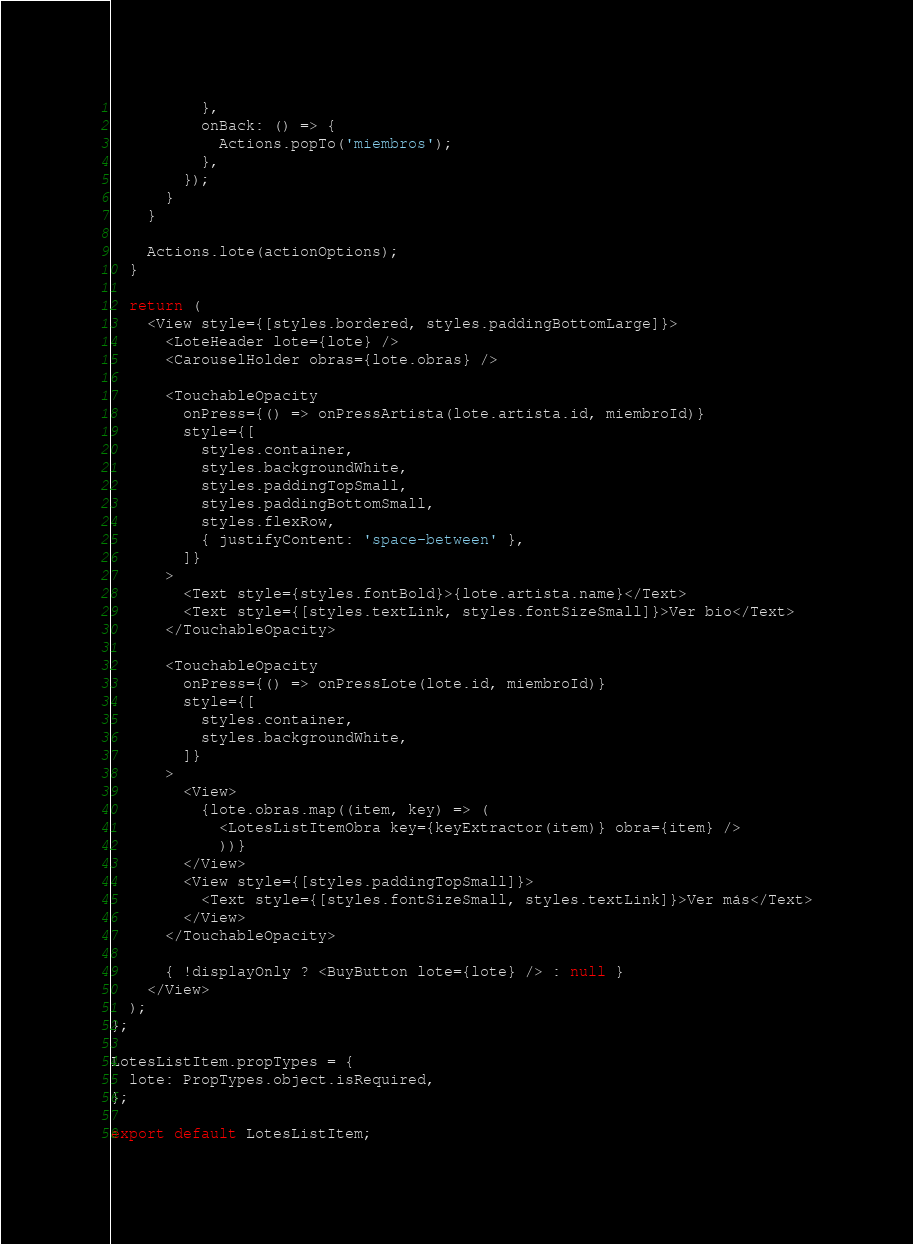<code> <loc_0><loc_0><loc_500><loc_500><_JavaScript_>          },
          onBack: () => {
            Actions.popTo('miembros');
          },
        });
      }
    }

    Actions.lote(actionOptions);
  }

  return (
    <View style={[styles.bordered, styles.paddingBottomLarge]}>
      <LoteHeader lote={lote} />
      <CarouselHolder obras={lote.obras} />

      <TouchableOpacity
        onPress={() => onPressArtista(lote.artista.id, miembroId)}
        style={[
          styles.container,
          styles.backgroundWhite,
          styles.paddingTopSmall,
          styles.paddingBottomSmall,
          styles.flexRow,
          { justifyContent: 'space-between' },
        ]}
      >
        <Text style={styles.fontBold}>{lote.artista.name}</Text>
        <Text style={[styles.textLink, styles.fontSizeSmall]}>Ver bio</Text>
      </TouchableOpacity>

      <TouchableOpacity
        onPress={() => onPressLote(lote.id, miembroId)}
        style={[
          styles.container,
          styles.backgroundWhite,
        ]}
      >
        <View>
          {lote.obras.map((item, key) => (
            <LotesListItemObra key={keyExtractor(item)} obra={item} />
            ))}
        </View>
        <View style={[styles.paddingTopSmall]}>
          <Text style={[styles.fontSizeSmall, styles.textLink]}>Ver más</Text>
        </View>
      </TouchableOpacity>

      { !displayOnly ? <BuyButton lote={lote} /> : null }
    </View>
  );
};

LotesListItem.propTypes = {
  lote: PropTypes.object.isRequired,
};

export default LotesListItem;
</code> 